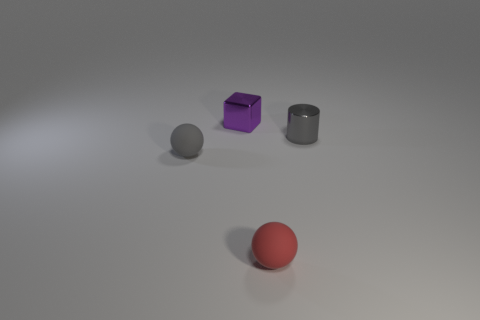Are there any other things that have the same shape as the small gray metallic thing?
Make the answer very short. No. Does the rubber thing behind the red rubber ball have the same color as the cylinder?
Offer a terse response. Yes. What number of matte things are either cubes or small green cylinders?
Offer a terse response. 0. What color is the tiny thing that is made of the same material as the gray sphere?
Provide a succinct answer. Red. How many cylinders are either red matte objects or tiny purple things?
Provide a succinct answer. 0. What number of objects are either tiny yellow blocks or objects behind the small shiny cylinder?
Keep it short and to the point. 1. Is there a large yellow ball?
Provide a succinct answer. No. What number of shiny things have the same color as the cube?
Provide a short and direct response. 0. What is the material of the small ball that is the same color as the shiny cylinder?
Make the answer very short. Rubber. How big is the metal object that is left of the small shiny thing right of the small red matte thing?
Give a very brief answer. Small. 